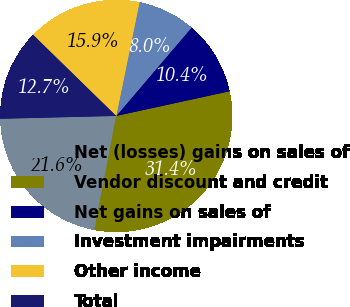<chart> <loc_0><loc_0><loc_500><loc_500><pie_chart><fcel>Net (losses) gains on sales of<fcel>Vendor discount and credit<fcel>Net gains on sales of<fcel>Investment impairments<fcel>Other income<fcel>Total<nl><fcel>21.6%<fcel>31.42%<fcel>10.36%<fcel>8.02%<fcel>15.91%<fcel>12.7%<nl></chart> 